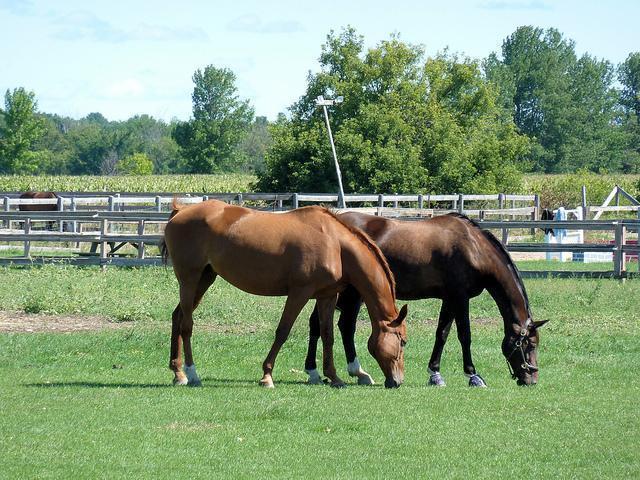Who likely owns these horses?
Choose the right answer and clarify with the format: 'Answer: answer
Rationale: rationale.'
Options: Circus, rancher, zookeeper, jockey. Answer: rancher.
Rationale: The horses are on a ranch. 